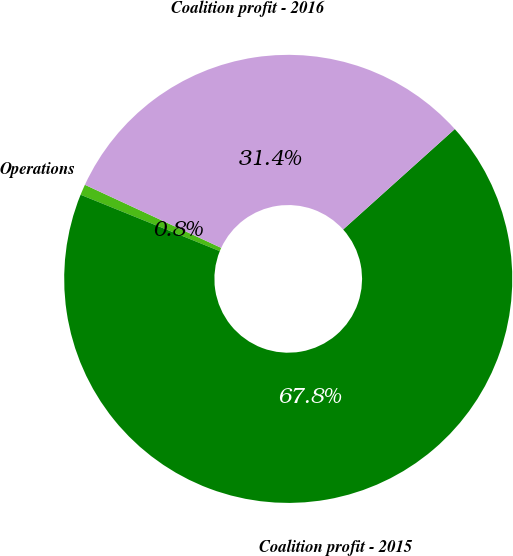<chart> <loc_0><loc_0><loc_500><loc_500><pie_chart><fcel>Operations<fcel>Coalition profit - 2015<fcel>Coalition profit - 2016<nl><fcel>0.77%<fcel>67.78%<fcel>31.44%<nl></chart> 